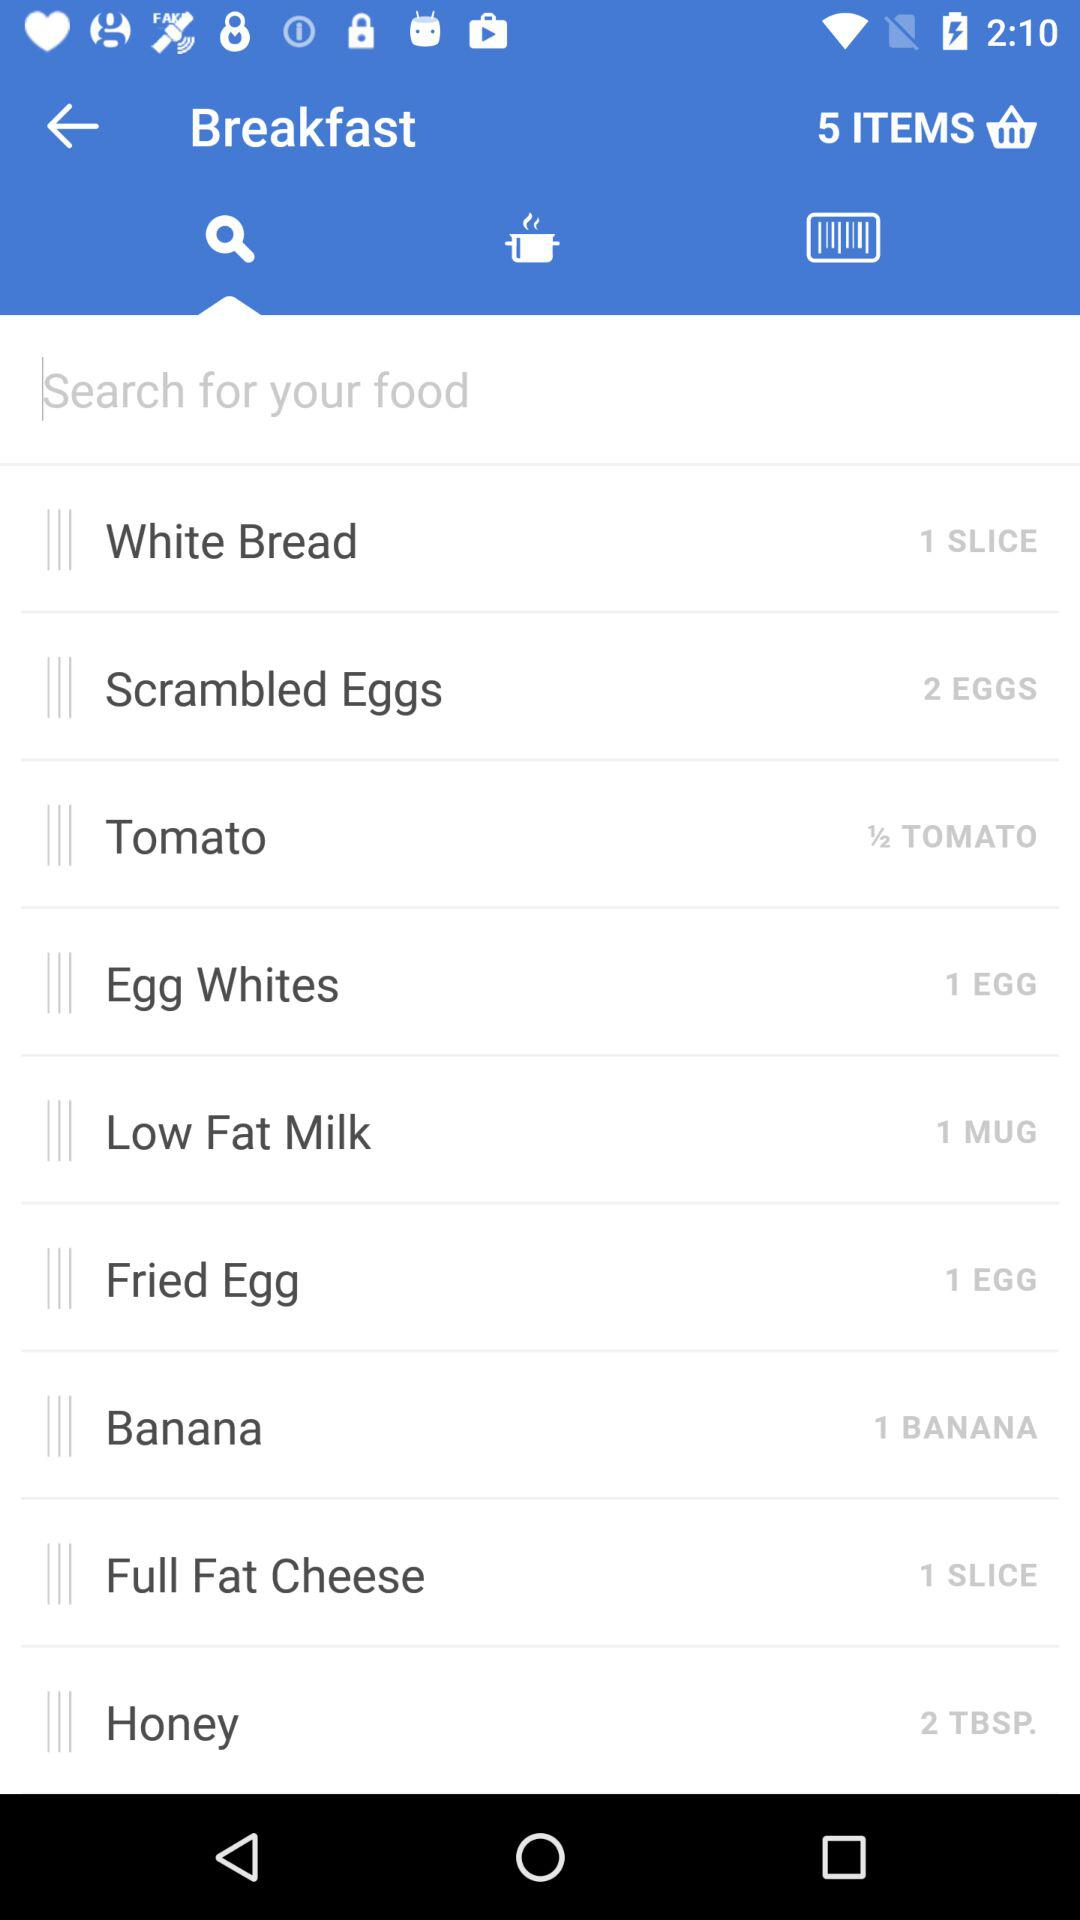How many items are added to the basket? The number of items added to the basket is 5. 